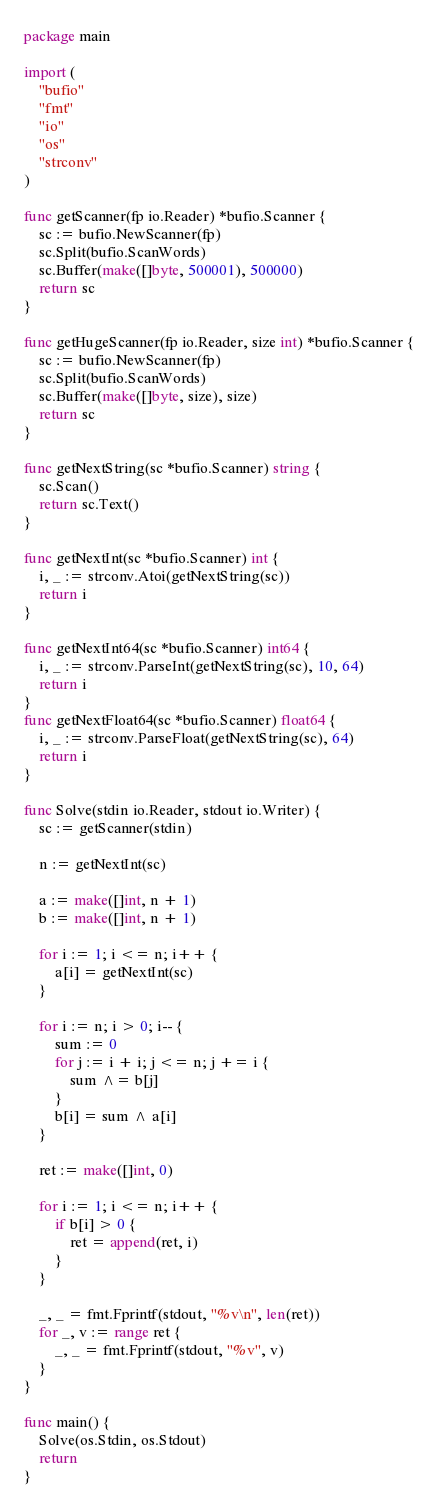<code> <loc_0><loc_0><loc_500><loc_500><_Go_>package main

import (
	"bufio"
	"fmt"
	"io"
	"os"
	"strconv"
)

func getScanner(fp io.Reader) *bufio.Scanner {
	sc := bufio.NewScanner(fp)
	sc.Split(bufio.ScanWords)
	sc.Buffer(make([]byte, 500001), 500000)
	return sc
}

func getHugeScanner(fp io.Reader, size int) *bufio.Scanner {
	sc := bufio.NewScanner(fp)
	sc.Split(bufio.ScanWords)
	sc.Buffer(make([]byte, size), size)
	return sc
}

func getNextString(sc *bufio.Scanner) string {
	sc.Scan()
	return sc.Text()
}

func getNextInt(sc *bufio.Scanner) int {
	i, _ := strconv.Atoi(getNextString(sc))
	return i
}

func getNextInt64(sc *bufio.Scanner) int64 {
	i, _ := strconv.ParseInt(getNextString(sc), 10, 64)
	return i
}
func getNextFloat64(sc *bufio.Scanner) float64 {
	i, _ := strconv.ParseFloat(getNextString(sc), 64)
	return i
}

func Solve(stdin io.Reader, stdout io.Writer) {
	sc := getScanner(stdin)

	n := getNextInt(sc)

	a := make([]int, n + 1)
	b := make([]int, n + 1)

	for i := 1; i <= n; i++ {
		a[i] = getNextInt(sc)
	}

	for i := n; i > 0; i-- {
		sum := 0
		for j := i + i; j <= n; j += i {
			sum ^= b[j]
		}
		b[i] = sum ^ a[i]
	}

	ret := make([]int, 0)

	for i := 1; i <= n; i++ {
		if b[i] > 0 {
			ret = append(ret, i)
		}
	}

	_, _ = fmt.Fprintf(stdout, "%v\n", len(ret))
	for _, v := range ret {
		_, _ = fmt.Fprintf(stdout, "%v", v)
	}
}

func main() {
	Solve(os.Stdin, os.Stdout)
	return
}</code> 